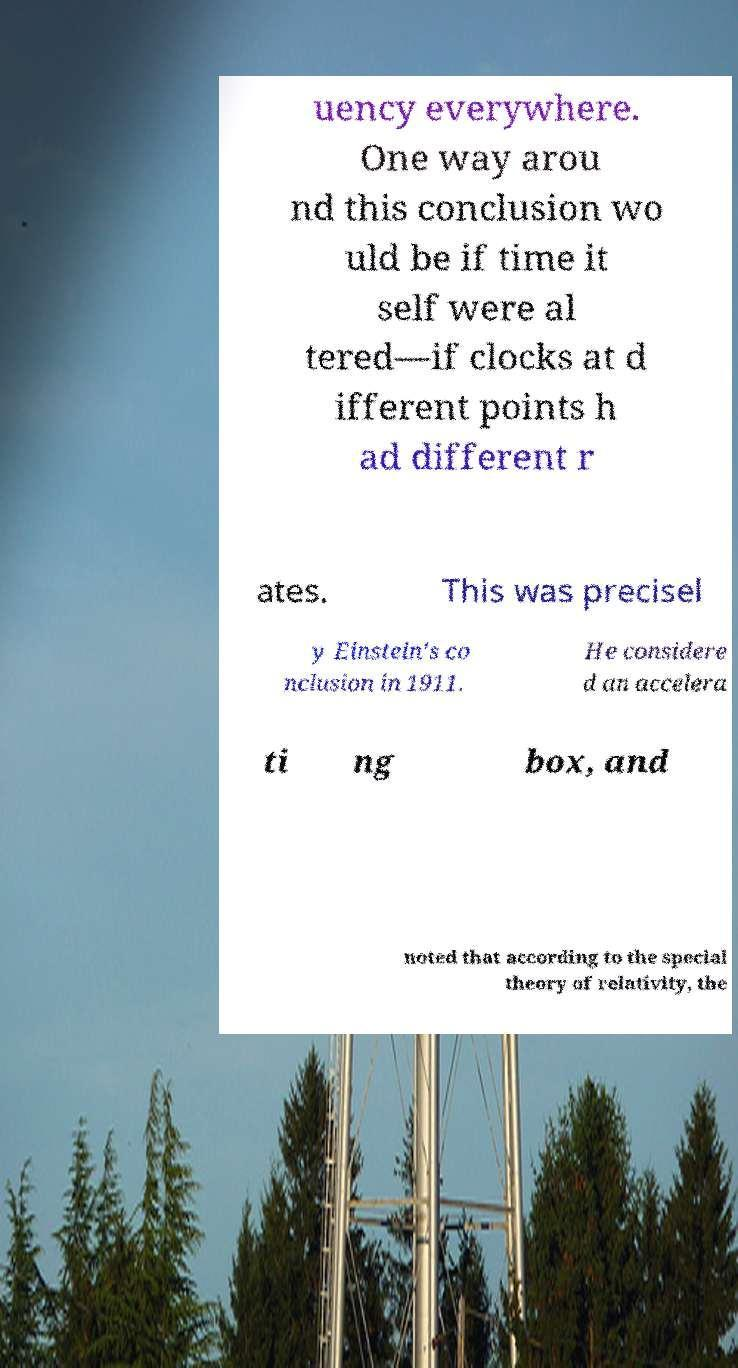Could you assist in decoding the text presented in this image and type it out clearly? uency everywhere. One way arou nd this conclusion wo uld be if time it self were al tered—if clocks at d ifferent points h ad different r ates. This was precisel y Einstein's co nclusion in 1911. He considere d an accelera ti ng box, and noted that according to the special theory of relativity, the 